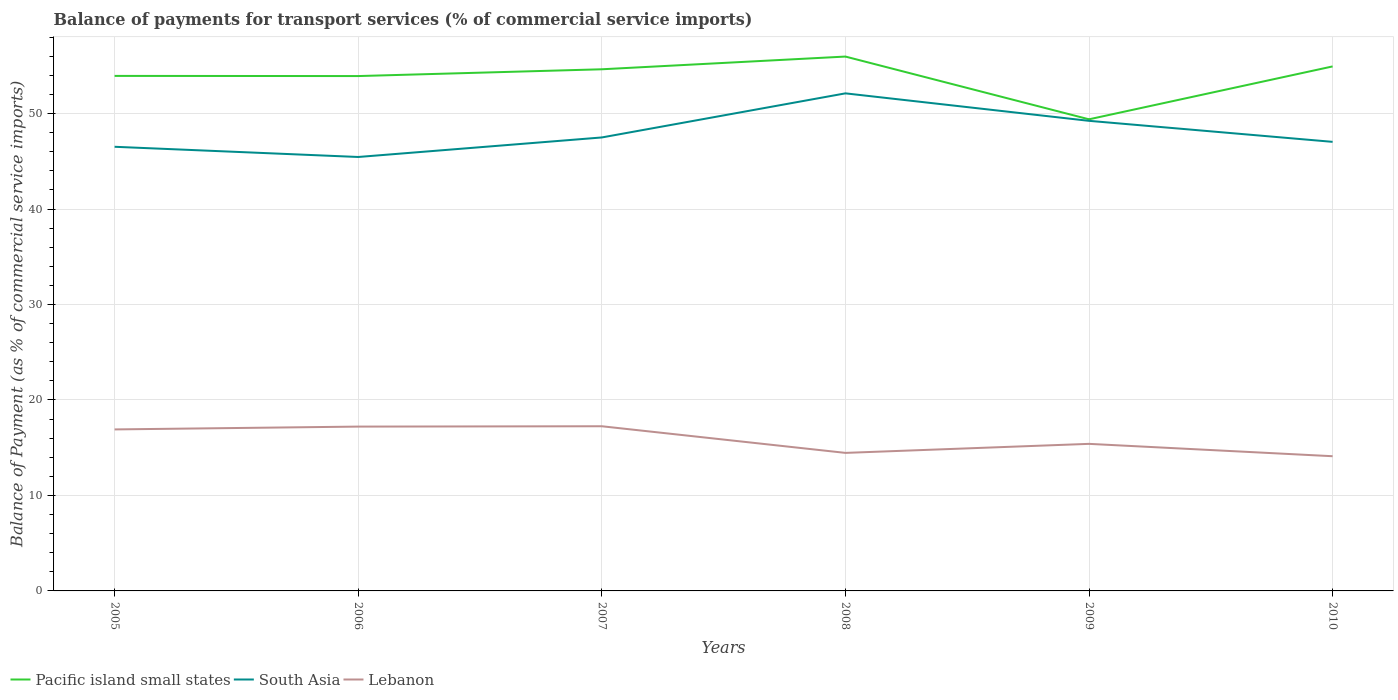How many different coloured lines are there?
Your answer should be very brief. 3. Across all years, what is the maximum balance of payments for transport services in Pacific island small states?
Provide a short and direct response. 49.4. In which year was the balance of payments for transport services in Lebanon maximum?
Offer a very short reply. 2010. What is the total balance of payments for transport services in Lebanon in the graph?
Give a very brief answer. 2.79. What is the difference between the highest and the second highest balance of payments for transport services in Pacific island small states?
Give a very brief answer. 6.57. What is the difference between the highest and the lowest balance of payments for transport services in Lebanon?
Give a very brief answer. 3. What is the difference between two consecutive major ticks on the Y-axis?
Ensure brevity in your answer.  10. Does the graph contain grids?
Keep it short and to the point. Yes. Where does the legend appear in the graph?
Provide a succinct answer. Bottom left. How many legend labels are there?
Provide a short and direct response. 3. What is the title of the graph?
Make the answer very short. Balance of payments for transport services (% of commercial service imports). Does "Aruba" appear as one of the legend labels in the graph?
Make the answer very short. No. What is the label or title of the Y-axis?
Give a very brief answer. Balance of Payment (as % of commercial service imports). What is the Balance of Payment (as % of commercial service imports) of Pacific island small states in 2005?
Your response must be concise. 53.95. What is the Balance of Payment (as % of commercial service imports) of South Asia in 2005?
Your response must be concise. 46.53. What is the Balance of Payment (as % of commercial service imports) in Lebanon in 2005?
Your response must be concise. 16.92. What is the Balance of Payment (as % of commercial service imports) of Pacific island small states in 2006?
Your answer should be compact. 53.93. What is the Balance of Payment (as % of commercial service imports) of South Asia in 2006?
Make the answer very short. 45.46. What is the Balance of Payment (as % of commercial service imports) in Lebanon in 2006?
Your response must be concise. 17.21. What is the Balance of Payment (as % of commercial service imports) of Pacific island small states in 2007?
Make the answer very short. 54.64. What is the Balance of Payment (as % of commercial service imports) of South Asia in 2007?
Make the answer very short. 47.5. What is the Balance of Payment (as % of commercial service imports) in Lebanon in 2007?
Make the answer very short. 17.25. What is the Balance of Payment (as % of commercial service imports) of Pacific island small states in 2008?
Provide a short and direct response. 55.98. What is the Balance of Payment (as % of commercial service imports) of South Asia in 2008?
Offer a very short reply. 52.12. What is the Balance of Payment (as % of commercial service imports) in Lebanon in 2008?
Your response must be concise. 14.46. What is the Balance of Payment (as % of commercial service imports) of Pacific island small states in 2009?
Make the answer very short. 49.4. What is the Balance of Payment (as % of commercial service imports) of South Asia in 2009?
Your response must be concise. 49.24. What is the Balance of Payment (as % of commercial service imports) in Lebanon in 2009?
Your answer should be compact. 15.41. What is the Balance of Payment (as % of commercial service imports) in Pacific island small states in 2010?
Your answer should be very brief. 54.94. What is the Balance of Payment (as % of commercial service imports) of South Asia in 2010?
Ensure brevity in your answer.  47.04. What is the Balance of Payment (as % of commercial service imports) of Lebanon in 2010?
Ensure brevity in your answer.  14.11. Across all years, what is the maximum Balance of Payment (as % of commercial service imports) in Pacific island small states?
Keep it short and to the point. 55.98. Across all years, what is the maximum Balance of Payment (as % of commercial service imports) in South Asia?
Give a very brief answer. 52.12. Across all years, what is the maximum Balance of Payment (as % of commercial service imports) of Lebanon?
Offer a very short reply. 17.25. Across all years, what is the minimum Balance of Payment (as % of commercial service imports) of Pacific island small states?
Keep it short and to the point. 49.4. Across all years, what is the minimum Balance of Payment (as % of commercial service imports) of South Asia?
Provide a short and direct response. 45.46. Across all years, what is the minimum Balance of Payment (as % of commercial service imports) of Lebanon?
Ensure brevity in your answer.  14.11. What is the total Balance of Payment (as % of commercial service imports) in Pacific island small states in the graph?
Offer a very short reply. 322.85. What is the total Balance of Payment (as % of commercial service imports) in South Asia in the graph?
Offer a very short reply. 287.89. What is the total Balance of Payment (as % of commercial service imports) of Lebanon in the graph?
Your response must be concise. 95.36. What is the difference between the Balance of Payment (as % of commercial service imports) in Pacific island small states in 2005 and that in 2006?
Provide a short and direct response. 0.02. What is the difference between the Balance of Payment (as % of commercial service imports) in South Asia in 2005 and that in 2006?
Make the answer very short. 1.07. What is the difference between the Balance of Payment (as % of commercial service imports) of Lebanon in 2005 and that in 2006?
Provide a short and direct response. -0.3. What is the difference between the Balance of Payment (as % of commercial service imports) in Pacific island small states in 2005 and that in 2007?
Keep it short and to the point. -0.69. What is the difference between the Balance of Payment (as % of commercial service imports) in South Asia in 2005 and that in 2007?
Provide a short and direct response. -0.98. What is the difference between the Balance of Payment (as % of commercial service imports) in Lebanon in 2005 and that in 2007?
Your answer should be very brief. -0.33. What is the difference between the Balance of Payment (as % of commercial service imports) of Pacific island small states in 2005 and that in 2008?
Provide a succinct answer. -2.03. What is the difference between the Balance of Payment (as % of commercial service imports) of South Asia in 2005 and that in 2008?
Give a very brief answer. -5.6. What is the difference between the Balance of Payment (as % of commercial service imports) of Lebanon in 2005 and that in 2008?
Provide a short and direct response. 2.46. What is the difference between the Balance of Payment (as % of commercial service imports) of Pacific island small states in 2005 and that in 2009?
Give a very brief answer. 4.55. What is the difference between the Balance of Payment (as % of commercial service imports) in South Asia in 2005 and that in 2009?
Provide a short and direct response. -2.72. What is the difference between the Balance of Payment (as % of commercial service imports) in Lebanon in 2005 and that in 2009?
Your answer should be compact. 1.51. What is the difference between the Balance of Payment (as % of commercial service imports) in Pacific island small states in 2005 and that in 2010?
Your response must be concise. -0.99. What is the difference between the Balance of Payment (as % of commercial service imports) in South Asia in 2005 and that in 2010?
Offer a terse response. -0.52. What is the difference between the Balance of Payment (as % of commercial service imports) in Lebanon in 2005 and that in 2010?
Your answer should be compact. 2.81. What is the difference between the Balance of Payment (as % of commercial service imports) in Pacific island small states in 2006 and that in 2007?
Your response must be concise. -0.71. What is the difference between the Balance of Payment (as % of commercial service imports) of South Asia in 2006 and that in 2007?
Make the answer very short. -2.05. What is the difference between the Balance of Payment (as % of commercial service imports) of Lebanon in 2006 and that in 2007?
Ensure brevity in your answer.  -0.04. What is the difference between the Balance of Payment (as % of commercial service imports) of Pacific island small states in 2006 and that in 2008?
Make the answer very short. -2.04. What is the difference between the Balance of Payment (as % of commercial service imports) in South Asia in 2006 and that in 2008?
Offer a very short reply. -6.67. What is the difference between the Balance of Payment (as % of commercial service imports) of Lebanon in 2006 and that in 2008?
Provide a short and direct response. 2.75. What is the difference between the Balance of Payment (as % of commercial service imports) of Pacific island small states in 2006 and that in 2009?
Provide a succinct answer. 4.53. What is the difference between the Balance of Payment (as % of commercial service imports) in South Asia in 2006 and that in 2009?
Offer a terse response. -3.79. What is the difference between the Balance of Payment (as % of commercial service imports) of Lebanon in 2006 and that in 2009?
Your answer should be compact. 1.81. What is the difference between the Balance of Payment (as % of commercial service imports) of Pacific island small states in 2006 and that in 2010?
Offer a terse response. -1.01. What is the difference between the Balance of Payment (as % of commercial service imports) of South Asia in 2006 and that in 2010?
Keep it short and to the point. -1.59. What is the difference between the Balance of Payment (as % of commercial service imports) of Lebanon in 2006 and that in 2010?
Offer a terse response. 3.1. What is the difference between the Balance of Payment (as % of commercial service imports) of Pacific island small states in 2007 and that in 2008?
Your answer should be compact. -1.33. What is the difference between the Balance of Payment (as % of commercial service imports) in South Asia in 2007 and that in 2008?
Provide a short and direct response. -4.62. What is the difference between the Balance of Payment (as % of commercial service imports) of Lebanon in 2007 and that in 2008?
Ensure brevity in your answer.  2.79. What is the difference between the Balance of Payment (as % of commercial service imports) of Pacific island small states in 2007 and that in 2009?
Your answer should be compact. 5.24. What is the difference between the Balance of Payment (as % of commercial service imports) of South Asia in 2007 and that in 2009?
Offer a very short reply. -1.74. What is the difference between the Balance of Payment (as % of commercial service imports) in Lebanon in 2007 and that in 2009?
Your answer should be compact. 1.84. What is the difference between the Balance of Payment (as % of commercial service imports) of Pacific island small states in 2007 and that in 2010?
Offer a very short reply. -0.3. What is the difference between the Balance of Payment (as % of commercial service imports) of South Asia in 2007 and that in 2010?
Your answer should be compact. 0.46. What is the difference between the Balance of Payment (as % of commercial service imports) of Lebanon in 2007 and that in 2010?
Provide a succinct answer. 3.14. What is the difference between the Balance of Payment (as % of commercial service imports) in Pacific island small states in 2008 and that in 2009?
Your response must be concise. 6.57. What is the difference between the Balance of Payment (as % of commercial service imports) of South Asia in 2008 and that in 2009?
Provide a short and direct response. 2.88. What is the difference between the Balance of Payment (as % of commercial service imports) of Lebanon in 2008 and that in 2009?
Provide a short and direct response. -0.95. What is the difference between the Balance of Payment (as % of commercial service imports) of Pacific island small states in 2008 and that in 2010?
Your answer should be compact. 1.03. What is the difference between the Balance of Payment (as % of commercial service imports) in South Asia in 2008 and that in 2010?
Your response must be concise. 5.08. What is the difference between the Balance of Payment (as % of commercial service imports) of Lebanon in 2008 and that in 2010?
Offer a very short reply. 0.35. What is the difference between the Balance of Payment (as % of commercial service imports) of Pacific island small states in 2009 and that in 2010?
Provide a succinct answer. -5.54. What is the difference between the Balance of Payment (as % of commercial service imports) of South Asia in 2009 and that in 2010?
Your answer should be compact. 2.2. What is the difference between the Balance of Payment (as % of commercial service imports) of Lebanon in 2009 and that in 2010?
Your response must be concise. 1.3. What is the difference between the Balance of Payment (as % of commercial service imports) in Pacific island small states in 2005 and the Balance of Payment (as % of commercial service imports) in South Asia in 2006?
Provide a short and direct response. 8.49. What is the difference between the Balance of Payment (as % of commercial service imports) in Pacific island small states in 2005 and the Balance of Payment (as % of commercial service imports) in Lebanon in 2006?
Offer a terse response. 36.74. What is the difference between the Balance of Payment (as % of commercial service imports) of South Asia in 2005 and the Balance of Payment (as % of commercial service imports) of Lebanon in 2006?
Offer a very short reply. 29.31. What is the difference between the Balance of Payment (as % of commercial service imports) in Pacific island small states in 2005 and the Balance of Payment (as % of commercial service imports) in South Asia in 2007?
Your answer should be very brief. 6.45. What is the difference between the Balance of Payment (as % of commercial service imports) of Pacific island small states in 2005 and the Balance of Payment (as % of commercial service imports) of Lebanon in 2007?
Make the answer very short. 36.7. What is the difference between the Balance of Payment (as % of commercial service imports) of South Asia in 2005 and the Balance of Payment (as % of commercial service imports) of Lebanon in 2007?
Provide a succinct answer. 29.28. What is the difference between the Balance of Payment (as % of commercial service imports) of Pacific island small states in 2005 and the Balance of Payment (as % of commercial service imports) of South Asia in 2008?
Your response must be concise. 1.83. What is the difference between the Balance of Payment (as % of commercial service imports) of Pacific island small states in 2005 and the Balance of Payment (as % of commercial service imports) of Lebanon in 2008?
Your response must be concise. 39.49. What is the difference between the Balance of Payment (as % of commercial service imports) in South Asia in 2005 and the Balance of Payment (as % of commercial service imports) in Lebanon in 2008?
Give a very brief answer. 32.07. What is the difference between the Balance of Payment (as % of commercial service imports) in Pacific island small states in 2005 and the Balance of Payment (as % of commercial service imports) in South Asia in 2009?
Give a very brief answer. 4.71. What is the difference between the Balance of Payment (as % of commercial service imports) of Pacific island small states in 2005 and the Balance of Payment (as % of commercial service imports) of Lebanon in 2009?
Ensure brevity in your answer.  38.54. What is the difference between the Balance of Payment (as % of commercial service imports) of South Asia in 2005 and the Balance of Payment (as % of commercial service imports) of Lebanon in 2009?
Ensure brevity in your answer.  31.12. What is the difference between the Balance of Payment (as % of commercial service imports) of Pacific island small states in 2005 and the Balance of Payment (as % of commercial service imports) of South Asia in 2010?
Make the answer very short. 6.91. What is the difference between the Balance of Payment (as % of commercial service imports) in Pacific island small states in 2005 and the Balance of Payment (as % of commercial service imports) in Lebanon in 2010?
Provide a short and direct response. 39.84. What is the difference between the Balance of Payment (as % of commercial service imports) in South Asia in 2005 and the Balance of Payment (as % of commercial service imports) in Lebanon in 2010?
Ensure brevity in your answer.  32.42. What is the difference between the Balance of Payment (as % of commercial service imports) of Pacific island small states in 2006 and the Balance of Payment (as % of commercial service imports) of South Asia in 2007?
Provide a short and direct response. 6.43. What is the difference between the Balance of Payment (as % of commercial service imports) of Pacific island small states in 2006 and the Balance of Payment (as % of commercial service imports) of Lebanon in 2007?
Give a very brief answer. 36.68. What is the difference between the Balance of Payment (as % of commercial service imports) in South Asia in 2006 and the Balance of Payment (as % of commercial service imports) in Lebanon in 2007?
Offer a terse response. 28.21. What is the difference between the Balance of Payment (as % of commercial service imports) in Pacific island small states in 2006 and the Balance of Payment (as % of commercial service imports) in South Asia in 2008?
Make the answer very short. 1.81. What is the difference between the Balance of Payment (as % of commercial service imports) in Pacific island small states in 2006 and the Balance of Payment (as % of commercial service imports) in Lebanon in 2008?
Offer a terse response. 39.47. What is the difference between the Balance of Payment (as % of commercial service imports) of South Asia in 2006 and the Balance of Payment (as % of commercial service imports) of Lebanon in 2008?
Offer a terse response. 31. What is the difference between the Balance of Payment (as % of commercial service imports) of Pacific island small states in 2006 and the Balance of Payment (as % of commercial service imports) of South Asia in 2009?
Provide a succinct answer. 4.69. What is the difference between the Balance of Payment (as % of commercial service imports) of Pacific island small states in 2006 and the Balance of Payment (as % of commercial service imports) of Lebanon in 2009?
Keep it short and to the point. 38.53. What is the difference between the Balance of Payment (as % of commercial service imports) of South Asia in 2006 and the Balance of Payment (as % of commercial service imports) of Lebanon in 2009?
Your response must be concise. 30.05. What is the difference between the Balance of Payment (as % of commercial service imports) of Pacific island small states in 2006 and the Balance of Payment (as % of commercial service imports) of South Asia in 2010?
Ensure brevity in your answer.  6.89. What is the difference between the Balance of Payment (as % of commercial service imports) in Pacific island small states in 2006 and the Balance of Payment (as % of commercial service imports) in Lebanon in 2010?
Ensure brevity in your answer.  39.82. What is the difference between the Balance of Payment (as % of commercial service imports) of South Asia in 2006 and the Balance of Payment (as % of commercial service imports) of Lebanon in 2010?
Keep it short and to the point. 31.35. What is the difference between the Balance of Payment (as % of commercial service imports) in Pacific island small states in 2007 and the Balance of Payment (as % of commercial service imports) in South Asia in 2008?
Offer a very short reply. 2.52. What is the difference between the Balance of Payment (as % of commercial service imports) in Pacific island small states in 2007 and the Balance of Payment (as % of commercial service imports) in Lebanon in 2008?
Your response must be concise. 40.18. What is the difference between the Balance of Payment (as % of commercial service imports) in South Asia in 2007 and the Balance of Payment (as % of commercial service imports) in Lebanon in 2008?
Provide a short and direct response. 33.04. What is the difference between the Balance of Payment (as % of commercial service imports) in Pacific island small states in 2007 and the Balance of Payment (as % of commercial service imports) in South Asia in 2009?
Your response must be concise. 5.4. What is the difference between the Balance of Payment (as % of commercial service imports) of Pacific island small states in 2007 and the Balance of Payment (as % of commercial service imports) of Lebanon in 2009?
Keep it short and to the point. 39.24. What is the difference between the Balance of Payment (as % of commercial service imports) in South Asia in 2007 and the Balance of Payment (as % of commercial service imports) in Lebanon in 2009?
Your answer should be compact. 32.1. What is the difference between the Balance of Payment (as % of commercial service imports) in Pacific island small states in 2007 and the Balance of Payment (as % of commercial service imports) in South Asia in 2010?
Give a very brief answer. 7.6. What is the difference between the Balance of Payment (as % of commercial service imports) in Pacific island small states in 2007 and the Balance of Payment (as % of commercial service imports) in Lebanon in 2010?
Give a very brief answer. 40.53. What is the difference between the Balance of Payment (as % of commercial service imports) in South Asia in 2007 and the Balance of Payment (as % of commercial service imports) in Lebanon in 2010?
Give a very brief answer. 33.39. What is the difference between the Balance of Payment (as % of commercial service imports) in Pacific island small states in 2008 and the Balance of Payment (as % of commercial service imports) in South Asia in 2009?
Keep it short and to the point. 6.73. What is the difference between the Balance of Payment (as % of commercial service imports) in Pacific island small states in 2008 and the Balance of Payment (as % of commercial service imports) in Lebanon in 2009?
Keep it short and to the point. 40.57. What is the difference between the Balance of Payment (as % of commercial service imports) of South Asia in 2008 and the Balance of Payment (as % of commercial service imports) of Lebanon in 2009?
Keep it short and to the point. 36.72. What is the difference between the Balance of Payment (as % of commercial service imports) of Pacific island small states in 2008 and the Balance of Payment (as % of commercial service imports) of South Asia in 2010?
Your answer should be very brief. 8.93. What is the difference between the Balance of Payment (as % of commercial service imports) of Pacific island small states in 2008 and the Balance of Payment (as % of commercial service imports) of Lebanon in 2010?
Make the answer very short. 41.87. What is the difference between the Balance of Payment (as % of commercial service imports) of South Asia in 2008 and the Balance of Payment (as % of commercial service imports) of Lebanon in 2010?
Provide a short and direct response. 38.01. What is the difference between the Balance of Payment (as % of commercial service imports) of Pacific island small states in 2009 and the Balance of Payment (as % of commercial service imports) of South Asia in 2010?
Your answer should be compact. 2.36. What is the difference between the Balance of Payment (as % of commercial service imports) in Pacific island small states in 2009 and the Balance of Payment (as % of commercial service imports) in Lebanon in 2010?
Your answer should be compact. 35.29. What is the difference between the Balance of Payment (as % of commercial service imports) in South Asia in 2009 and the Balance of Payment (as % of commercial service imports) in Lebanon in 2010?
Provide a succinct answer. 35.13. What is the average Balance of Payment (as % of commercial service imports) of Pacific island small states per year?
Ensure brevity in your answer.  53.81. What is the average Balance of Payment (as % of commercial service imports) in South Asia per year?
Make the answer very short. 47.98. What is the average Balance of Payment (as % of commercial service imports) of Lebanon per year?
Your answer should be compact. 15.89. In the year 2005, what is the difference between the Balance of Payment (as % of commercial service imports) of Pacific island small states and Balance of Payment (as % of commercial service imports) of South Asia?
Your answer should be compact. 7.42. In the year 2005, what is the difference between the Balance of Payment (as % of commercial service imports) of Pacific island small states and Balance of Payment (as % of commercial service imports) of Lebanon?
Offer a terse response. 37.03. In the year 2005, what is the difference between the Balance of Payment (as % of commercial service imports) of South Asia and Balance of Payment (as % of commercial service imports) of Lebanon?
Your response must be concise. 29.61. In the year 2006, what is the difference between the Balance of Payment (as % of commercial service imports) of Pacific island small states and Balance of Payment (as % of commercial service imports) of South Asia?
Ensure brevity in your answer.  8.48. In the year 2006, what is the difference between the Balance of Payment (as % of commercial service imports) of Pacific island small states and Balance of Payment (as % of commercial service imports) of Lebanon?
Offer a very short reply. 36.72. In the year 2006, what is the difference between the Balance of Payment (as % of commercial service imports) in South Asia and Balance of Payment (as % of commercial service imports) in Lebanon?
Offer a very short reply. 28.24. In the year 2007, what is the difference between the Balance of Payment (as % of commercial service imports) in Pacific island small states and Balance of Payment (as % of commercial service imports) in South Asia?
Make the answer very short. 7.14. In the year 2007, what is the difference between the Balance of Payment (as % of commercial service imports) in Pacific island small states and Balance of Payment (as % of commercial service imports) in Lebanon?
Give a very brief answer. 37.39. In the year 2007, what is the difference between the Balance of Payment (as % of commercial service imports) in South Asia and Balance of Payment (as % of commercial service imports) in Lebanon?
Your response must be concise. 30.25. In the year 2008, what is the difference between the Balance of Payment (as % of commercial service imports) in Pacific island small states and Balance of Payment (as % of commercial service imports) in South Asia?
Give a very brief answer. 3.85. In the year 2008, what is the difference between the Balance of Payment (as % of commercial service imports) of Pacific island small states and Balance of Payment (as % of commercial service imports) of Lebanon?
Keep it short and to the point. 41.52. In the year 2008, what is the difference between the Balance of Payment (as % of commercial service imports) in South Asia and Balance of Payment (as % of commercial service imports) in Lebanon?
Provide a succinct answer. 37.66. In the year 2009, what is the difference between the Balance of Payment (as % of commercial service imports) of Pacific island small states and Balance of Payment (as % of commercial service imports) of South Asia?
Your answer should be compact. 0.16. In the year 2009, what is the difference between the Balance of Payment (as % of commercial service imports) in Pacific island small states and Balance of Payment (as % of commercial service imports) in Lebanon?
Your answer should be compact. 34. In the year 2009, what is the difference between the Balance of Payment (as % of commercial service imports) of South Asia and Balance of Payment (as % of commercial service imports) of Lebanon?
Give a very brief answer. 33.84. In the year 2010, what is the difference between the Balance of Payment (as % of commercial service imports) in Pacific island small states and Balance of Payment (as % of commercial service imports) in South Asia?
Offer a very short reply. 7.9. In the year 2010, what is the difference between the Balance of Payment (as % of commercial service imports) of Pacific island small states and Balance of Payment (as % of commercial service imports) of Lebanon?
Make the answer very short. 40.83. In the year 2010, what is the difference between the Balance of Payment (as % of commercial service imports) of South Asia and Balance of Payment (as % of commercial service imports) of Lebanon?
Make the answer very short. 32.93. What is the ratio of the Balance of Payment (as % of commercial service imports) in South Asia in 2005 to that in 2006?
Your answer should be compact. 1.02. What is the ratio of the Balance of Payment (as % of commercial service imports) in Lebanon in 2005 to that in 2006?
Ensure brevity in your answer.  0.98. What is the ratio of the Balance of Payment (as % of commercial service imports) in Pacific island small states in 2005 to that in 2007?
Keep it short and to the point. 0.99. What is the ratio of the Balance of Payment (as % of commercial service imports) of South Asia in 2005 to that in 2007?
Keep it short and to the point. 0.98. What is the ratio of the Balance of Payment (as % of commercial service imports) in Lebanon in 2005 to that in 2007?
Make the answer very short. 0.98. What is the ratio of the Balance of Payment (as % of commercial service imports) in Pacific island small states in 2005 to that in 2008?
Your answer should be very brief. 0.96. What is the ratio of the Balance of Payment (as % of commercial service imports) of South Asia in 2005 to that in 2008?
Keep it short and to the point. 0.89. What is the ratio of the Balance of Payment (as % of commercial service imports) of Lebanon in 2005 to that in 2008?
Offer a very short reply. 1.17. What is the ratio of the Balance of Payment (as % of commercial service imports) in Pacific island small states in 2005 to that in 2009?
Keep it short and to the point. 1.09. What is the ratio of the Balance of Payment (as % of commercial service imports) in South Asia in 2005 to that in 2009?
Offer a terse response. 0.94. What is the ratio of the Balance of Payment (as % of commercial service imports) in Lebanon in 2005 to that in 2009?
Give a very brief answer. 1.1. What is the ratio of the Balance of Payment (as % of commercial service imports) of Pacific island small states in 2005 to that in 2010?
Your response must be concise. 0.98. What is the ratio of the Balance of Payment (as % of commercial service imports) of Lebanon in 2005 to that in 2010?
Your answer should be very brief. 1.2. What is the ratio of the Balance of Payment (as % of commercial service imports) in Pacific island small states in 2006 to that in 2007?
Give a very brief answer. 0.99. What is the ratio of the Balance of Payment (as % of commercial service imports) in South Asia in 2006 to that in 2007?
Give a very brief answer. 0.96. What is the ratio of the Balance of Payment (as % of commercial service imports) of Pacific island small states in 2006 to that in 2008?
Provide a succinct answer. 0.96. What is the ratio of the Balance of Payment (as % of commercial service imports) in South Asia in 2006 to that in 2008?
Provide a short and direct response. 0.87. What is the ratio of the Balance of Payment (as % of commercial service imports) of Lebanon in 2006 to that in 2008?
Keep it short and to the point. 1.19. What is the ratio of the Balance of Payment (as % of commercial service imports) in Pacific island small states in 2006 to that in 2009?
Give a very brief answer. 1.09. What is the ratio of the Balance of Payment (as % of commercial service imports) in South Asia in 2006 to that in 2009?
Keep it short and to the point. 0.92. What is the ratio of the Balance of Payment (as % of commercial service imports) in Lebanon in 2006 to that in 2009?
Offer a terse response. 1.12. What is the ratio of the Balance of Payment (as % of commercial service imports) in Pacific island small states in 2006 to that in 2010?
Provide a succinct answer. 0.98. What is the ratio of the Balance of Payment (as % of commercial service imports) in South Asia in 2006 to that in 2010?
Ensure brevity in your answer.  0.97. What is the ratio of the Balance of Payment (as % of commercial service imports) of Lebanon in 2006 to that in 2010?
Ensure brevity in your answer.  1.22. What is the ratio of the Balance of Payment (as % of commercial service imports) in Pacific island small states in 2007 to that in 2008?
Provide a succinct answer. 0.98. What is the ratio of the Balance of Payment (as % of commercial service imports) of South Asia in 2007 to that in 2008?
Give a very brief answer. 0.91. What is the ratio of the Balance of Payment (as % of commercial service imports) in Lebanon in 2007 to that in 2008?
Ensure brevity in your answer.  1.19. What is the ratio of the Balance of Payment (as % of commercial service imports) in Pacific island small states in 2007 to that in 2009?
Offer a terse response. 1.11. What is the ratio of the Balance of Payment (as % of commercial service imports) of South Asia in 2007 to that in 2009?
Keep it short and to the point. 0.96. What is the ratio of the Balance of Payment (as % of commercial service imports) of Lebanon in 2007 to that in 2009?
Give a very brief answer. 1.12. What is the ratio of the Balance of Payment (as % of commercial service imports) in Pacific island small states in 2007 to that in 2010?
Your response must be concise. 0.99. What is the ratio of the Balance of Payment (as % of commercial service imports) of South Asia in 2007 to that in 2010?
Keep it short and to the point. 1.01. What is the ratio of the Balance of Payment (as % of commercial service imports) in Lebanon in 2007 to that in 2010?
Offer a very short reply. 1.22. What is the ratio of the Balance of Payment (as % of commercial service imports) of Pacific island small states in 2008 to that in 2009?
Provide a short and direct response. 1.13. What is the ratio of the Balance of Payment (as % of commercial service imports) in South Asia in 2008 to that in 2009?
Offer a very short reply. 1.06. What is the ratio of the Balance of Payment (as % of commercial service imports) in Lebanon in 2008 to that in 2009?
Make the answer very short. 0.94. What is the ratio of the Balance of Payment (as % of commercial service imports) in Pacific island small states in 2008 to that in 2010?
Your answer should be very brief. 1.02. What is the ratio of the Balance of Payment (as % of commercial service imports) of South Asia in 2008 to that in 2010?
Your answer should be very brief. 1.11. What is the ratio of the Balance of Payment (as % of commercial service imports) in Lebanon in 2008 to that in 2010?
Provide a short and direct response. 1.02. What is the ratio of the Balance of Payment (as % of commercial service imports) of Pacific island small states in 2009 to that in 2010?
Provide a succinct answer. 0.9. What is the ratio of the Balance of Payment (as % of commercial service imports) in South Asia in 2009 to that in 2010?
Offer a terse response. 1.05. What is the ratio of the Balance of Payment (as % of commercial service imports) in Lebanon in 2009 to that in 2010?
Ensure brevity in your answer.  1.09. What is the difference between the highest and the second highest Balance of Payment (as % of commercial service imports) in Pacific island small states?
Provide a short and direct response. 1.03. What is the difference between the highest and the second highest Balance of Payment (as % of commercial service imports) of South Asia?
Offer a terse response. 2.88. What is the difference between the highest and the second highest Balance of Payment (as % of commercial service imports) in Lebanon?
Provide a short and direct response. 0.04. What is the difference between the highest and the lowest Balance of Payment (as % of commercial service imports) in Pacific island small states?
Ensure brevity in your answer.  6.57. What is the difference between the highest and the lowest Balance of Payment (as % of commercial service imports) in South Asia?
Your answer should be compact. 6.67. What is the difference between the highest and the lowest Balance of Payment (as % of commercial service imports) in Lebanon?
Provide a succinct answer. 3.14. 